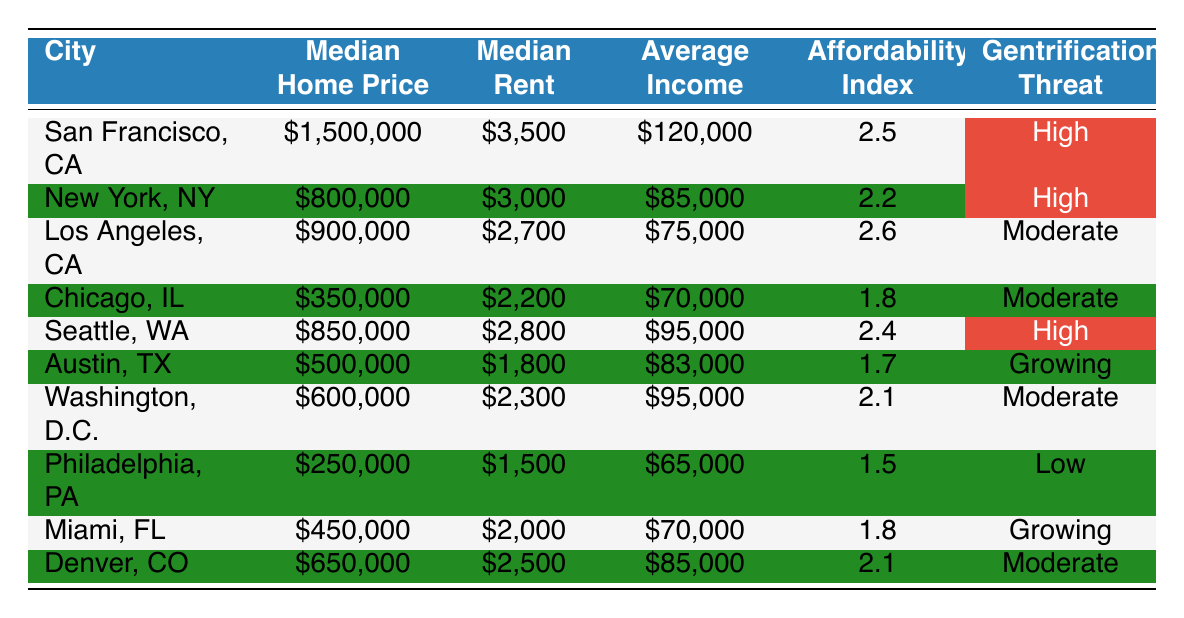What is the median home price in San Francisco, CA? The table directly shows that the median home price for San Francisco, CA is listed as $1,500,000.
Answer: $1,500,000 Which city has the highest median rent? By comparing the 'Median Rent' values in the table, San Francisco has the highest rent at $3,500.
Answer: San Francisco, CA Calculate the average home price of all cities listed in the table. The total median home prices for the cities are $1,500,000 + $800,000 + $900,000 + $350,000 + $850,000 + $500,000 + $600,000 + $250,000 + $450,000 + $650,000 = $6,900,000. There are 10 cities, so the average is $6,900,000 / 10 = $690,000.
Answer: $690,000 What percentage of cities have a high gentrification threat? There are 3 cities with a high gentrification threat out of 10 total cities. To find the percentage: (3/10) * 100 = 30%.
Answer: 30% Is the affordability index higher for Los Angeles or Chicago? The affordability index for Los Angeles is 2.6 and for Chicago, it is 1.8. Since 2.6 > 1.8, Los Angeles has a higher index.
Answer: Los Angeles What is the difference in median home price between Seattle and Philadelphia? The median home price for Seattle is $850,000 and for Philadelphia, it is $250,000. The difference is $850,000 - $250,000 = $600,000.
Answer: $600,000 Which city has the lowest affordability index, and what is that value? By examining the affordability index values, Philadelphia has the lowest index at 1.5.
Answer: Philadelphia, 1.5 What is the average income for cities with a high gentrification threat? The average incomes for cities with high gentrification threat are $120,000 (San Francisco) + $85,000 (New York) + $95,000 (Seattle) = $300,000. Divided by the 3 cities gives an average of $300,000 / 3 = $100,000.
Answer: $100,000 True or False: The median rent in Austin, TX is lower than the median rent in Los Angeles, CA. The table shows Austin's median rent is $1,800, and Los Angeles' is $2,700. Since $1,800 < $2,700, this statement is true.
Answer: True What is the total median rent paid by the 10 cities listed? Adding up all the median rents: $3,500 (SF) + $3,000 (NY) + $2,700 (LA) + $2,200 (Chicago) + $2,800 (Seattle) + $1,800 (Austin) + $2,300 (D.C.) + $1,500 (Philly) + $2,000 (Miami) + $2,500 (Denver) = $24,300.
Answer: $24,300 